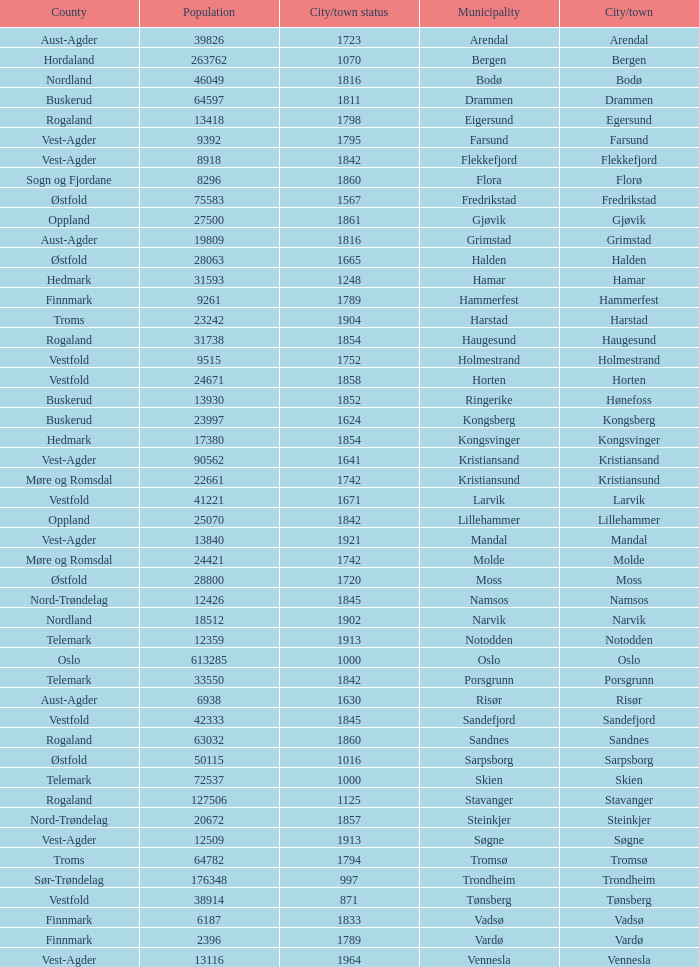What are the cities/towns located in the municipality of Moss? Moss. Parse the full table. {'header': ['County', 'Population', 'City/town status', 'Municipality', 'City/town'], 'rows': [['Aust-Agder', '39826', '1723', 'Arendal', 'Arendal'], ['Hordaland', '263762', '1070', 'Bergen', 'Bergen'], ['Nordland', '46049', '1816', 'Bodø', 'Bodø'], ['Buskerud', '64597', '1811', 'Drammen', 'Drammen'], ['Rogaland', '13418', '1798', 'Eigersund', 'Egersund'], ['Vest-Agder', '9392', '1795', 'Farsund', 'Farsund'], ['Vest-Agder', '8918', '1842', 'Flekkefjord', 'Flekkefjord'], ['Sogn og Fjordane', '8296', '1860', 'Flora', 'Florø'], ['Østfold', '75583', '1567', 'Fredrikstad', 'Fredrikstad'], ['Oppland', '27500', '1861', 'Gjøvik', 'Gjøvik'], ['Aust-Agder', '19809', '1816', 'Grimstad', 'Grimstad'], ['Østfold', '28063', '1665', 'Halden', 'Halden'], ['Hedmark', '31593', '1248', 'Hamar', 'Hamar'], ['Finnmark', '9261', '1789', 'Hammerfest', 'Hammerfest'], ['Troms', '23242', '1904', 'Harstad', 'Harstad'], ['Rogaland', '31738', '1854', 'Haugesund', 'Haugesund'], ['Vestfold', '9515', '1752', 'Holmestrand', 'Holmestrand'], ['Vestfold', '24671', '1858', 'Horten', 'Horten'], ['Buskerud', '13930', '1852', 'Ringerike', 'Hønefoss'], ['Buskerud', '23997', '1624', 'Kongsberg', 'Kongsberg'], ['Hedmark', '17380', '1854', 'Kongsvinger', 'Kongsvinger'], ['Vest-Agder', '90562', '1641', 'Kristiansand', 'Kristiansand'], ['Møre og Romsdal', '22661', '1742', 'Kristiansund', 'Kristiansund'], ['Vestfold', '41221', '1671', 'Larvik', 'Larvik'], ['Oppland', '25070', '1842', 'Lillehammer', 'Lillehammer'], ['Vest-Agder', '13840', '1921', 'Mandal', 'Mandal'], ['Møre og Romsdal', '24421', '1742', 'Molde', 'Molde'], ['Østfold', '28800', '1720', 'Moss', 'Moss'], ['Nord-Trøndelag', '12426', '1845', 'Namsos', 'Namsos'], ['Nordland', '18512', '1902', 'Narvik', 'Narvik'], ['Telemark', '12359', '1913', 'Notodden', 'Notodden'], ['Oslo', '613285', '1000', 'Oslo', 'Oslo'], ['Telemark', '33550', '1842', 'Porsgrunn', 'Porsgrunn'], ['Aust-Agder', '6938', '1630', 'Risør', 'Risør'], ['Vestfold', '42333', '1845', 'Sandefjord', 'Sandefjord'], ['Rogaland', '63032', '1860', 'Sandnes', 'Sandnes'], ['Østfold', '50115', '1016', 'Sarpsborg', 'Sarpsborg'], ['Telemark', '72537', '1000', 'Skien', 'Skien'], ['Rogaland', '127506', '1125', 'Stavanger', 'Stavanger'], ['Nord-Trøndelag', '20672', '1857', 'Steinkjer', 'Steinkjer'], ['Vest-Agder', '12509', '1913', 'Søgne', 'Søgne'], ['Troms', '64782', '1794', 'Tromsø', 'Tromsø'], ['Sør-Trøndelag', '176348', '997', 'Trondheim', 'Trondheim'], ['Vestfold', '38914', '871', 'Tønsberg', 'Tønsberg'], ['Finnmark', '6187', '1833', 'Vadsø', 'Vadsø'], ['Finnmark', '2396', '1789', 'Vardø', 'Vardø'], ['Vest-Agder', '13116', '1964', 'Vennesla', 'Vennesla']]} 